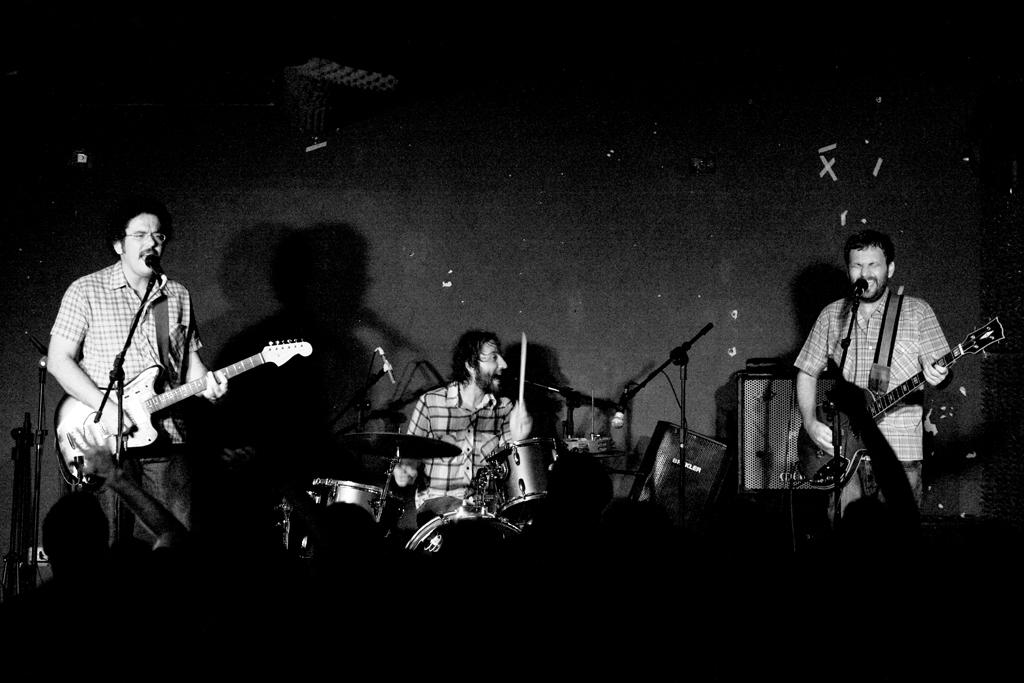What are the people in the image doing? The people in the image are playing musical instruments. What objects are present that might be used for amplifying sound? There are microphones in the image. What type of pancake is being used as a percussion instrument in the image? There is no pancake present in the image, and therefore no such instrument can be observed. 